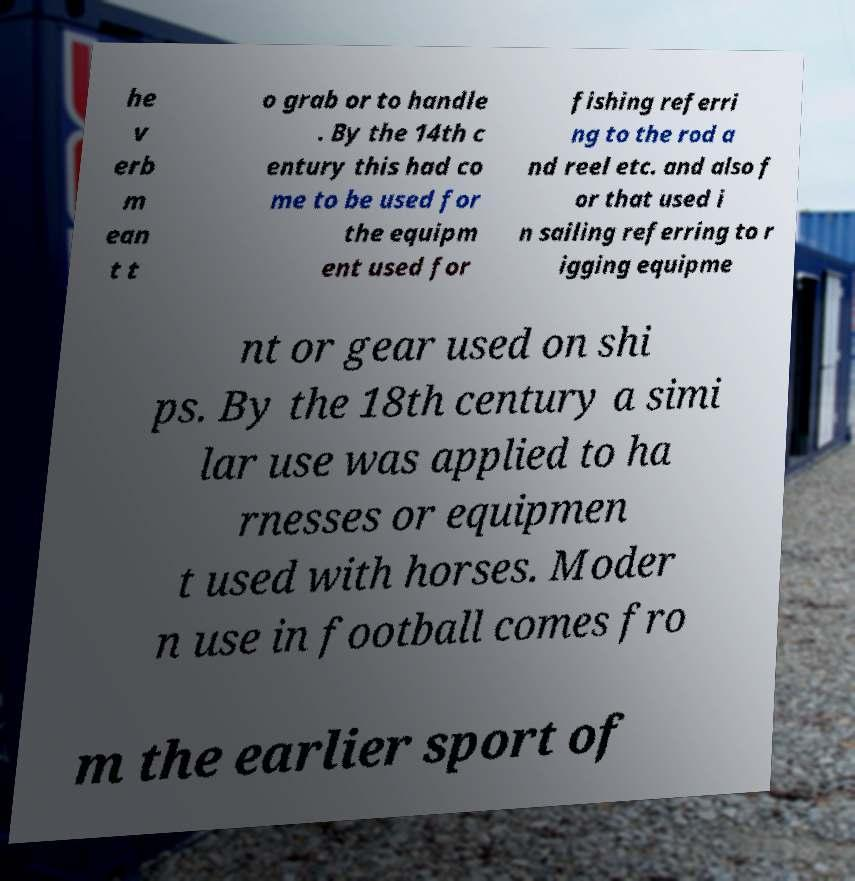Please identify and transcribe the text found in this image. he v erb m ean t t o grab or to handle . By the 14th c entury this had co me to be used for the equipm ent used for fishing referri ng to the rod a nd reel etc. and also f or that used i n sailing referring to r igging equipme nt or gear used on shi ps. By the 18th century a simi lar use was applied to ha rnesses or equipmen t used with horses. Moder n use in football comes fro m the earlier sport of 